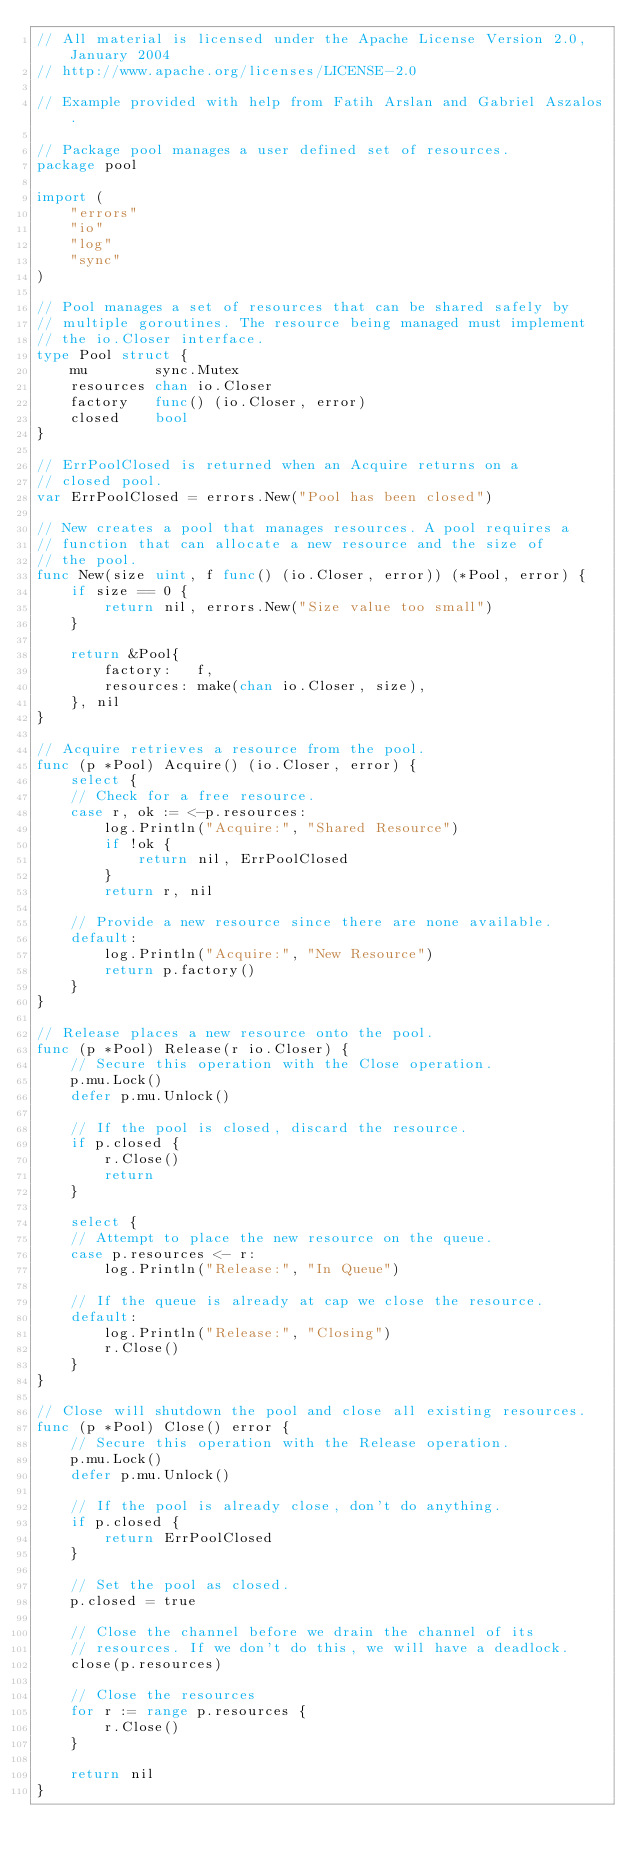Convert code to text. <code><loc_0><loc_0><loc_500><loc_500><_Go_>// All material is licensed under the Apache License Version 2.0, January 2004
// http://www.apache.org/licenses/LICENSE-2.0

// Example provided with help from Fatih Arslan and Gabriel Aszalos.

// Package pool manages a user defined set of resources.
package pool

import (
	"errors"
	"io"
	"log"
	"sync"
)

// Pool manages a set of resources that can be shared safely by
// multiple goroutines. The resource being managed must implement
// the io.Closer interface.
type Pool struct {
	mu        sync.Mutex
	resources chan io.Closer
	factory   func() (io.Closer, error)
	closed    bool
}

// ErrPoolClosed is returned when an Acquire returns on a
// closed pool.
var ErrPoolClosed = errors.New("Pool has been closed")

// New creates a pool that manages resources. A pool requires a
// function that can allocate a new resource and the size of
// the pool.
func New(size uint, f func() (io.Closer, error)) (*Pool, error) {
	if size == 0 {
		return nil, errors.New("Size value too small")
	}

	return &Pool{
		factory:   f,
		resources: make(chan io.Closer, size),
	}, nil
}

// Acquire retrieves a resource	from the pool.
func (p *Pool) Acquire() (io.Closer, error) {
	select {
	// Check for a free resource.
	case r, ok := <-p.resources:
		log.Println("Acquire:", "Shared Resource")
		if !ok {
			return nil, ErrPoolClosed
		}
		return r, nil

	// Provide a new resource since there are none available.
	default:
		log.Println("Acquire:", "New Resource")
		return p.factory()
	}
}

// Release places a new resource onto the pool.
func (p *Pool) Release(r io.Closer) {
	// Secure this operation with the Close operation.
	p.mu.Lock()
	defer p.mu.Unlock()

	// If the pool is closed, discard the resource.
	if p.closed {
		r.Close()
		return
	}

	select {
	// Attempt to place the new resource on the queue.
	case p.resources <- r:
		log.Println("Release:", "In Queue")

	// If the queue is already at cap we close the resource.
	default:
		log.Println("Release:", "Closing")
		r.Close()
	}
}

// Close will shutdown the pool and close all existing resources.
func (p *Pool) Close() error {
	// Secure this operation with the Release operation.
	p.mu.Lock()
	defer p.mu.Unlock()

	// If the pool is already close, don't do anything.
	if p.closed {
		return ErrPoolClosed
	}

	// Set the pool as closed.
	p.closed = true

	// Close the channel before we drain the channel of its
	// resources. If we don't do this, we will have a deadlock.
	close(p.resources)

	// Close the resources
	for r := range p.resources {
		r.Close()
	}

	return nil
}
</code> 